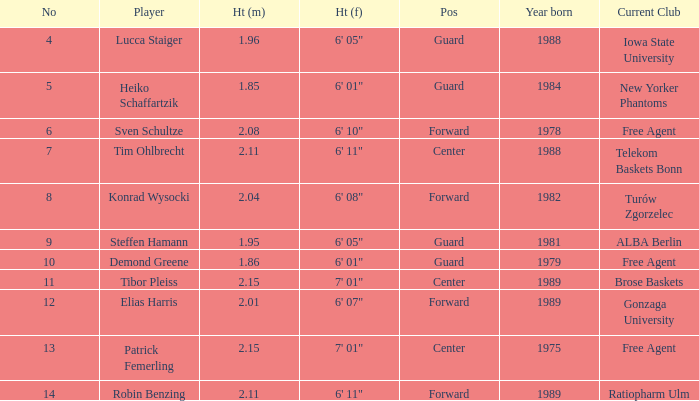Can you identify the athlete who stands at 1.85 meters tall? Heiko Schaffartzik. 